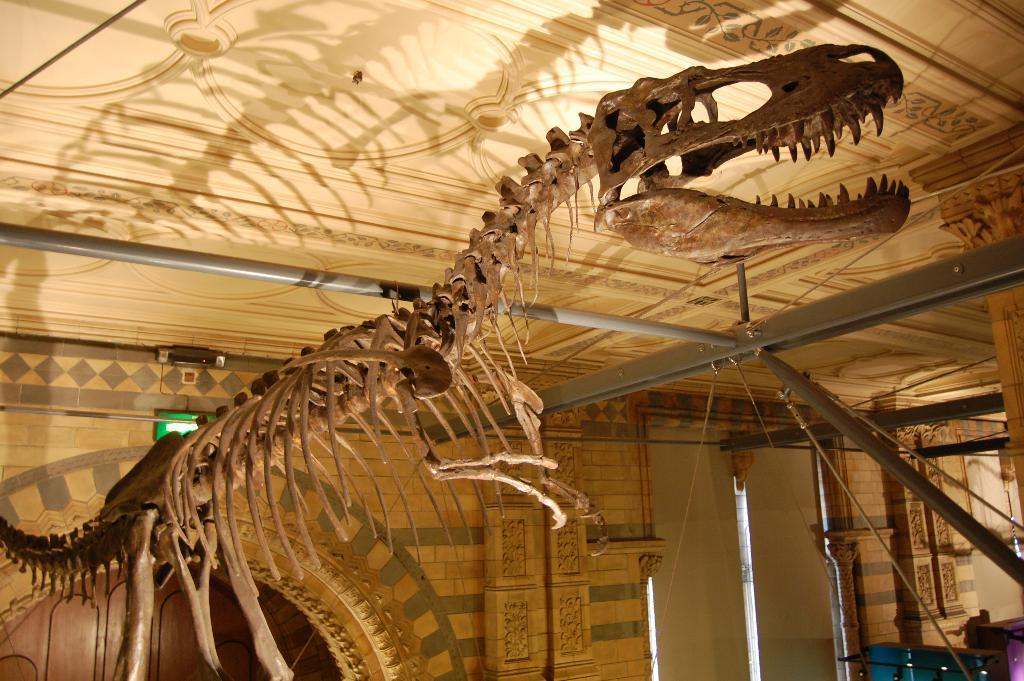What is the main subject of the image? The main subject of the image is a skeleton of an animal. Where is the skeleton located? The skeleton is under a roof. What other structures can be seen in the image? There is a door, metal poles, wires, a board, and a wall in the image. What type of crook can be seen interacting with the skeleton in the image? There is no crook present in the image, and therefore no such interaction can be observed. Is there a volcano visible in the image? No, there is no volcano present in the image. What is the material of the board in the image? The material of the board is not mentioned in the provided facts, so it cannot be determined from the image. 